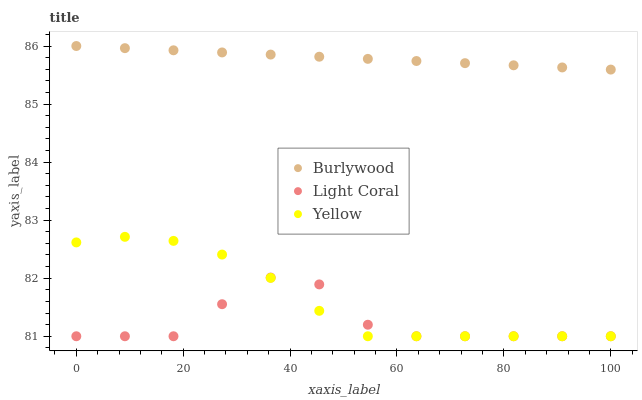Does Light Coral have the minimum area under the curve?
Answer yes or no. Yes. Does Burlywood have the maximum area under the curve?
Answer yes or no. Yes. Does Yellow have the minimum area under the curve?
Answer yes or no. No. Does Yellow have the maximum area under the curve?
Answer yes or no. No. Is Burlywood the smoothest?
Answer yes or no. Yes. Is Light Coral the roughest?
Answer yes or no. Yes. Is Yellow the smoothest?
Answer yes or no. No. Is Yellow the roughest?
Answer yes or no. No. Does Light Coral have the lowest value?
Answer yes or no. Yes. Does Burlywood have the highest value?
Answer yes or no. Yes. Does Yellow have the highest value?
Answer yes or no. No. Is Light Coral less than Burlywood?
Answer yes or no. Yes. Is Burlywood greater than Yellow?
Answer yes or no. Yes. Does Yellow intersect Light Coral?
Answer yes or no. Yes. Is Yellow less than Light Coral?
Answer yes or no. No. Is Yellow greater than Light Coral?
Answer yes or no. No. Does Light Coral intersect Burlywood?
Answer yes or no. No. 